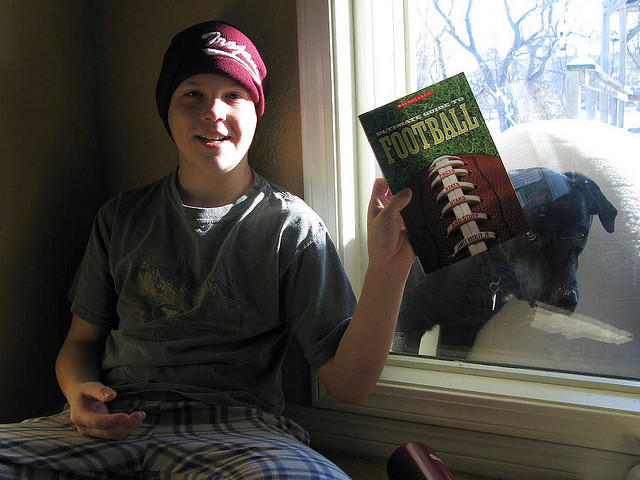Read and extract the text from this image. FOOTVALL FOOTBALL 